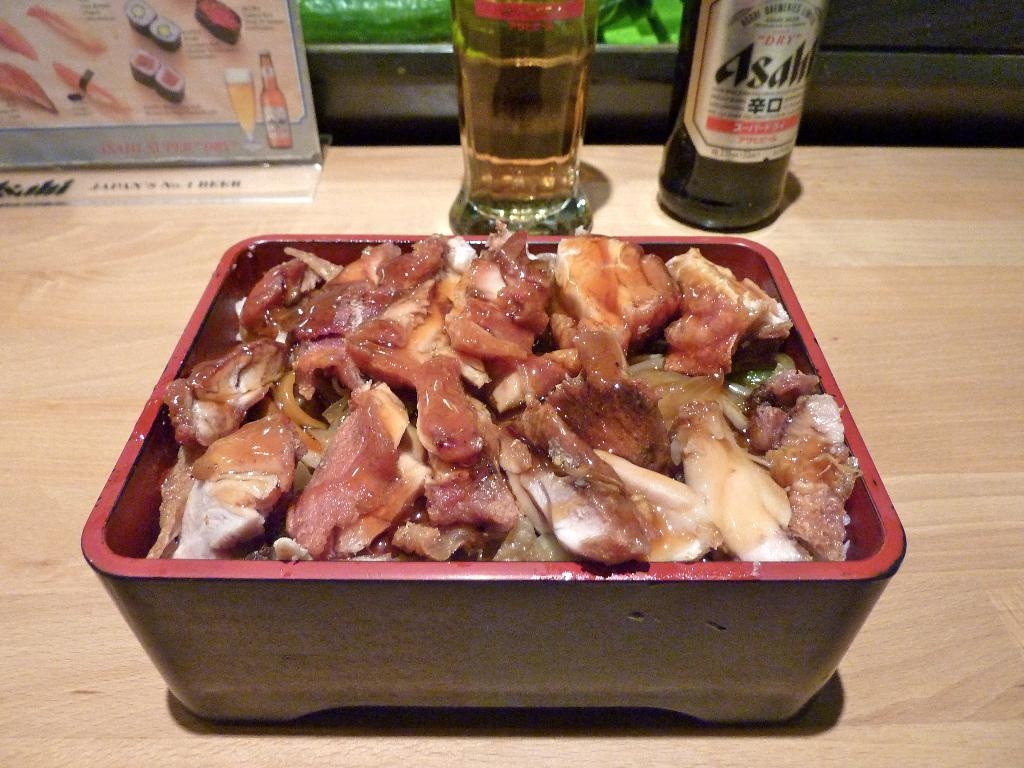What is in the bowl that is visible in the image? There is a bowl with meat in the image. Where is the bowl located in the image? The bowl is on a wooden table. What else can be seen on the table in the image? There are soft drink bottles in front of the bowl. What type of ship can be seen sailing in the background of the image? There is no ship visible in the image; it only features a bowl with meat, a wooden table, and soft drink bottles. 